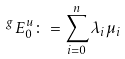Convert formula to latex. <formula><loc_0><loc_0><loc_500><loc_500>^ { g \, } E ^ { u } _ { 0 } \colon = \sum _ { i = 0 } ^ { n } \lambda _ { i } \mu _ { i }</formula> 